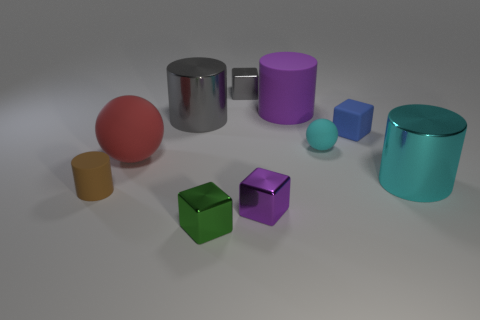Subtract all small gray metallic cubes. How many cubes are left? 3 Subtract 2 cylinders. How many cylinders are left? 2 Subtract all purple cylinders. How many cylinders are left? 3 Subtract all green cylinders. Subtract all cyan balls. How many cylinders are left? 4 Subtract 0 blue cylinders. How many objects are left? 10 Subtract all blocks. How many objects are left? 6 Subtract all blue shiny things. Subtract all gray objects. How many objects are left? 8 Add 8 metallic cylinders. How many metallic cylinders are left? 10 Add 1 big cyan rubber cylinders. How many big cyan rubber cylinders exist? 1 